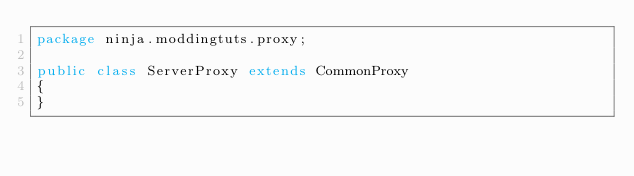<code> <loc_0><loc_0><loc_500><loc_500><_Java_>package ninja.moddingtuts.proxy;

public class ServerProxy extends CommonProxy
{
}
</code> 